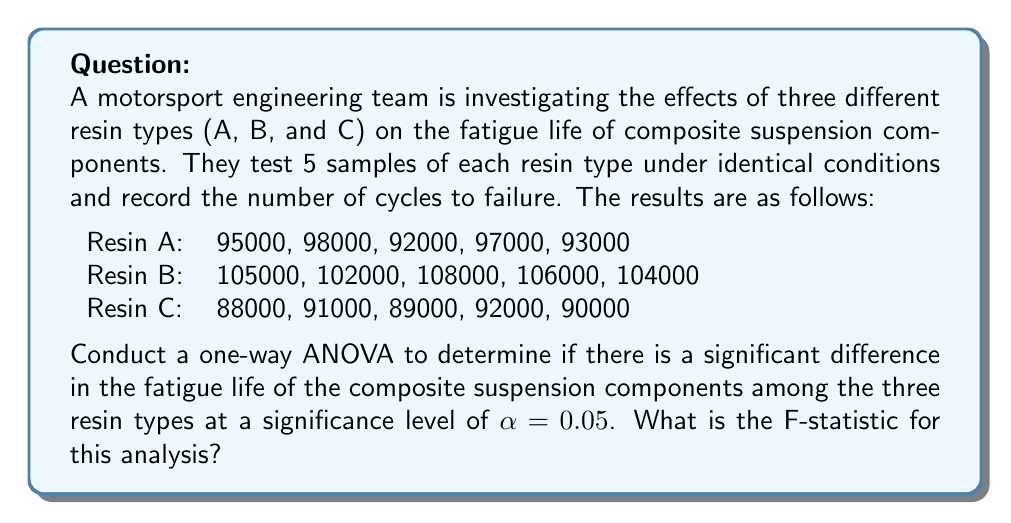Provide a solution to this math problem. To conduct a one-way ANOVA, we need to follow these steps:

1. Calculate the total sum of squares (SST)
2. Calculate the between-group sum of squares (SSB)
3. Calculate the within-group sum of squares (SSW)
4. Calculate the degrees of freedom
5. Calculate the mean squares
6. Calculate the F-statistic

Step 1: Calculate the total sum of squares (SST)
First, we need to find the grand mean:

$\bar{X} = \frac{95000 + 98000 + ... + 90000}{15} = 96666.67$

Now we can calculate SST:

$SST = \sum_{i=1}^{n} (X_i - \bar{X})^2 = (95000 - 96666.67)^2 + (98000 - 96666.67)^2 + ... + (90000 - 96666.67)^2 = 1066666666.67$

Step 2: Calculate the between-group sum of squares (SSB)
We need to find the mean for each group:

$\bar{X}_A = 95000$
$\bar{X}_B = 105000$
$\bar{X}_C = 90000$

Now we can calculate SSB:

$SSB = \sum_{i=1}^{k} n_i(\bar{X}_i - \bar{X})^2 = 5(95000 - 96666.67)^2 + 5(105000 - 96666.67)^2 + 5(90000 - 96666.67)^2 = 916666666.67$

Step 3: Calculate the within-group sum of squares (SSW)
$SSW = SST - SSB = 1066666666.67 - 916666666.67 = 150000000$

Step 4: Calculate the degrees of freedom
$df_{between} = k - 1 = 3 - 1 = 2$
$df_{within} = N - k = 15 - 3 = 12$
$df_{total} = N - 1 = 15 - 1 = 14$

Step 5: Calculate the mean squares
$MS_{between} = \frac{SSB}{df_{between}} = \frac{916666666.67}{2} = 458333333.33$
$MS_{within} = \frac{SSW}{df_{within}} = \frac{150000000}{12} = 12500000$

Step 6: Calculate the F-statistic
$F = \frac{MS_{between}}{MS_{within}} = \frac{458333333.33}{12500000} = 36.67$
Answer: The F-statistic for this one-way ANOVA is 36.67. 